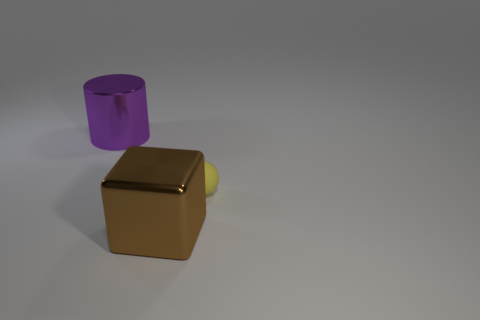What genre of photography does this image resemble? The image, featuring minimalistic objects with a plain background and a focus on the play of light and shadow, is reminiscent of product photography. This genre emphasizes the design and features of objects in a clear and aesthetically pleasing manner. 